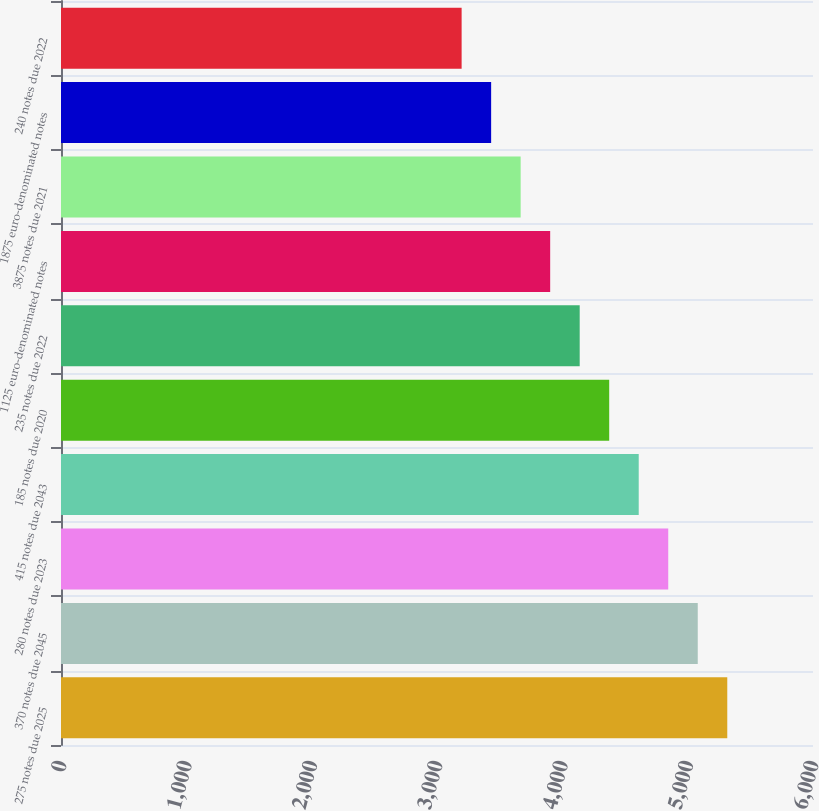Convert chart to OTSL. <chart><loc_0><loc_0><loc_500><loc_500><bar_chart><fcel>275 notes due 2025<fcel>370 notes due 2045<fcel>280 notes due 2023<fcel>415 notes due 2043<fcel>185 notes due 2020<fcel>235 notes due 2022<fcel>1125 euro-denominated notes<fcel>3875 notes due 2021<fcel>1875 euro-denominated notes<fcel>240 notes due 2022<nl><fcel>5316<fcel>5080.5<fcel>4845<fcel>4609.5<fcel>4374<fcel>4138.5<fcel>3903<fcel>3667.5<fcel>3432<fcel>3196.5<nl></chart> 